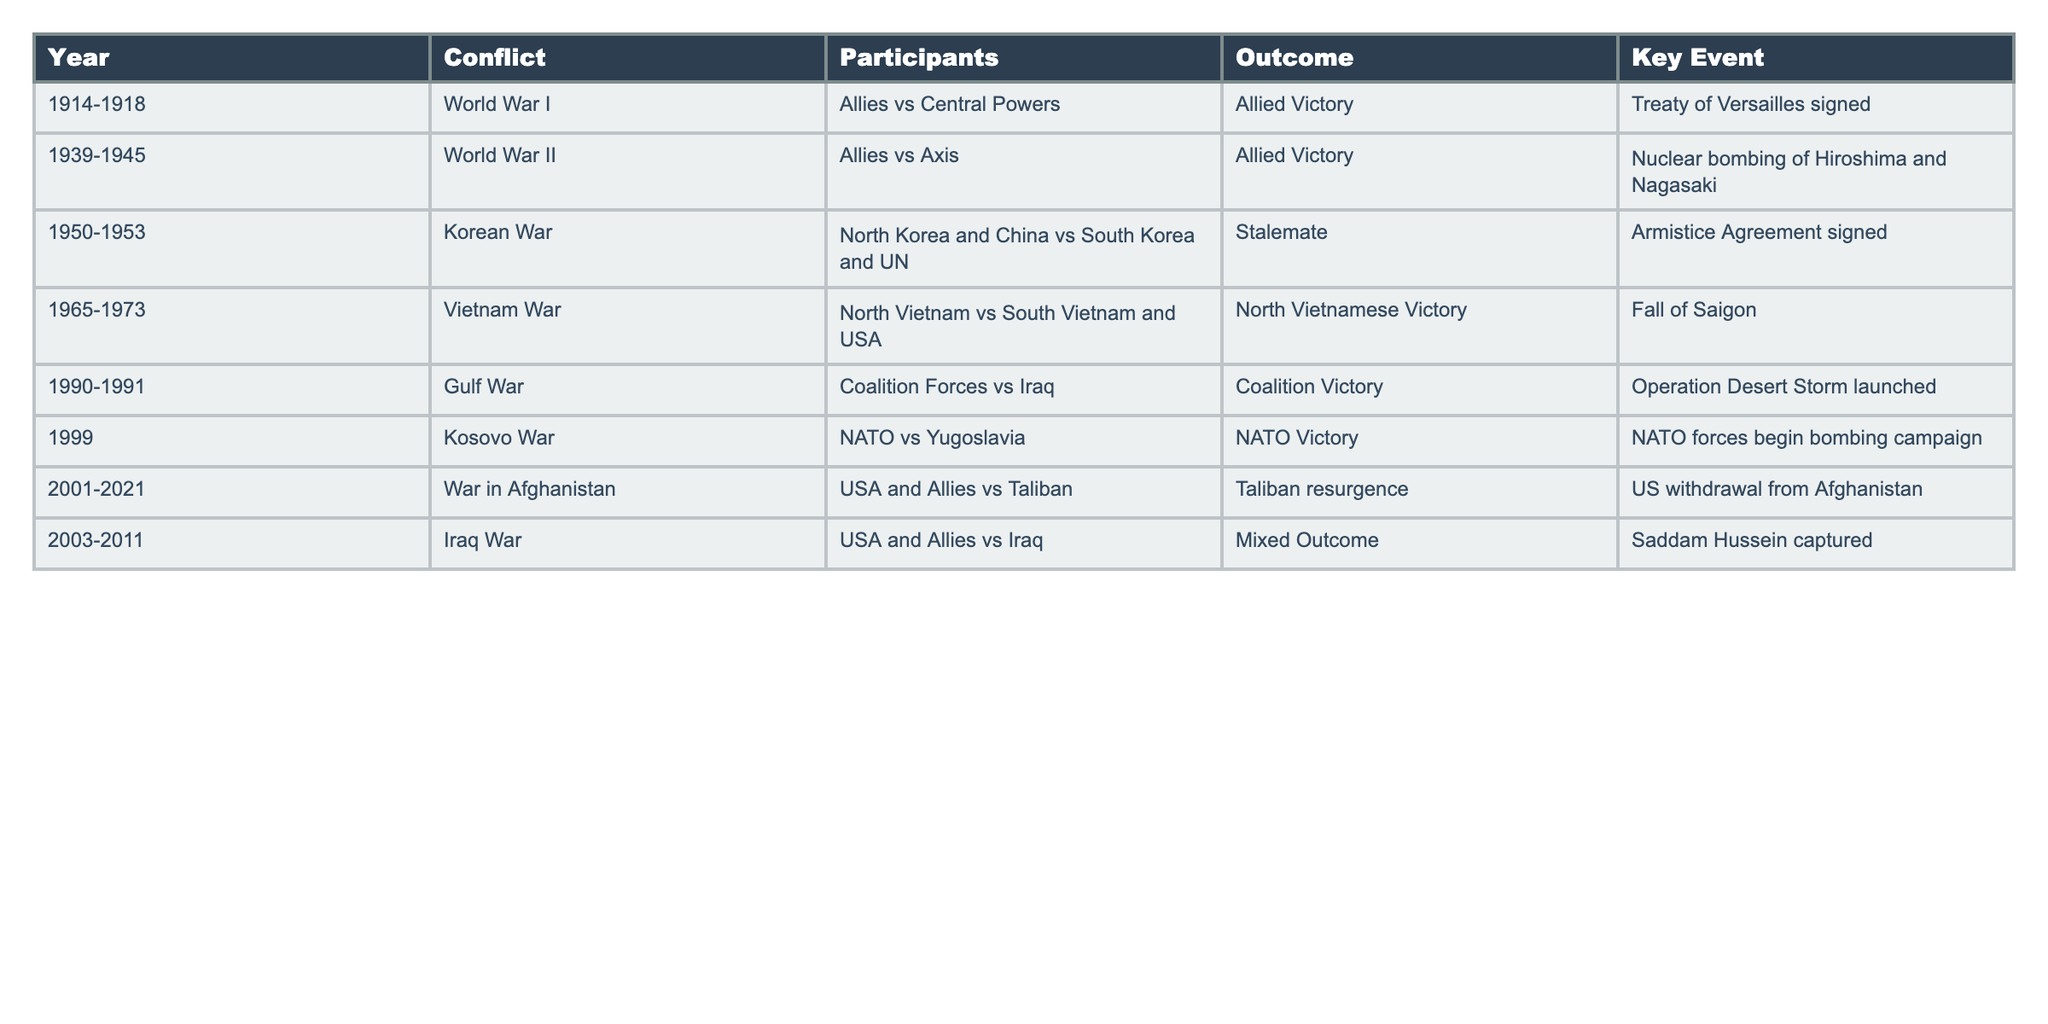What year did World War II take place? World War II occurred from 1939 to 1945, as indicated in the table under the 'Year' column for that conflict.
Answer: 1939-1945 Which conflict had a stalemate as its outcome? The Korean War is listed with a stalemate outcome in the 'Outcome' column.
Answer: Korean War How many conflicts resulted in Allied victories? Referring to the table, both World War I and World War II had outcomes of Allied Victory, totaling two conflicts.
Answer: 2 Was the Gulf War fought between NATO and Iraq? The table shows that the Gulf War involved Coalition Forces against Iraq, not NATO.
Answer: No What was the key event for the Iraq War? The table specifies that the key event for the Iraq War was the capturing of Saddam Hussein.
Answer: Saddam Hussein captured Did any conflict occur in 1999? If so, what was it? The table lists the Kosovo War as occurring in 1999, making it the only conflict for that year.
Answer: Kosovo War Which conflict had the longest duration? Comparing the years of all conflicts, World War I and World War II lasted the longest, with both spanning over four years each.
Answer: World War I and World War II In how many of the listed conflicts did the USA participate? Analyzing the table shows that the USA was involved in the Korean War, Vietnam War, Gulf War, War in Afghanistan, and Iraq War, totaling five conflicts.
Answer: 5 What was the outcome of the War in Afghanistan? According to the table, the War in Afghanistan resulted in a Taliban resurgence as its outcome.
Answer: Taliban resurgence Which conflict had the key event of the "Fall of Saigon"? The table indicates that the key event "Fall of Saigon" is associated with the Vietnam War.
Answer: Vietnam War Which conflict occurred immediately after World War II? The Korean War occurred directly after World War II, beginning in 1950.
Answer: Korean War 